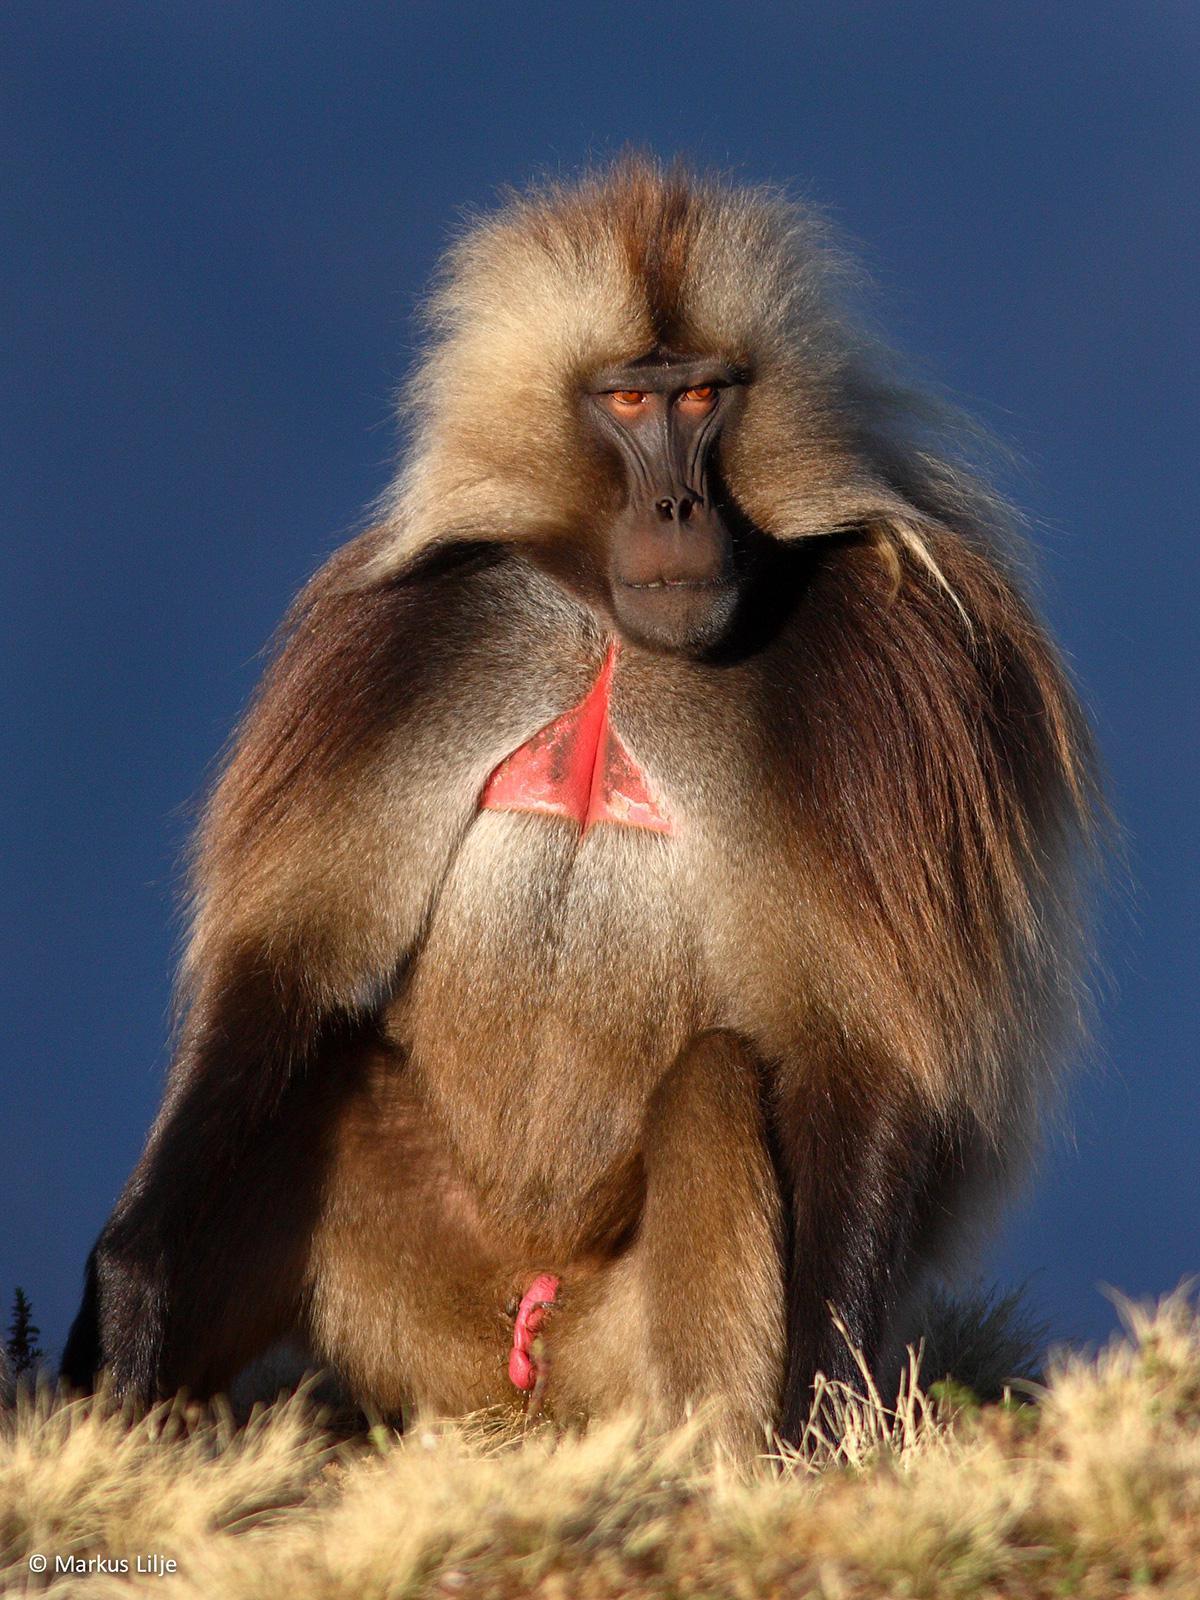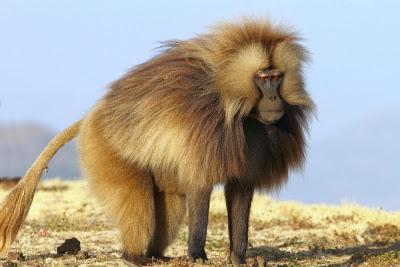The first image is the image on the left, the second image is the image on the right. Assess this claim about the two images: "in the right pic the primates fangs are fully shown". Correct or not? Answer yes or no. No. The first image is the image on the left, the second image is the image on the right. Assess this claim about the two images: "At least one baboon has a wide open mouth.". Correct or not? Answer yes or no. No. 